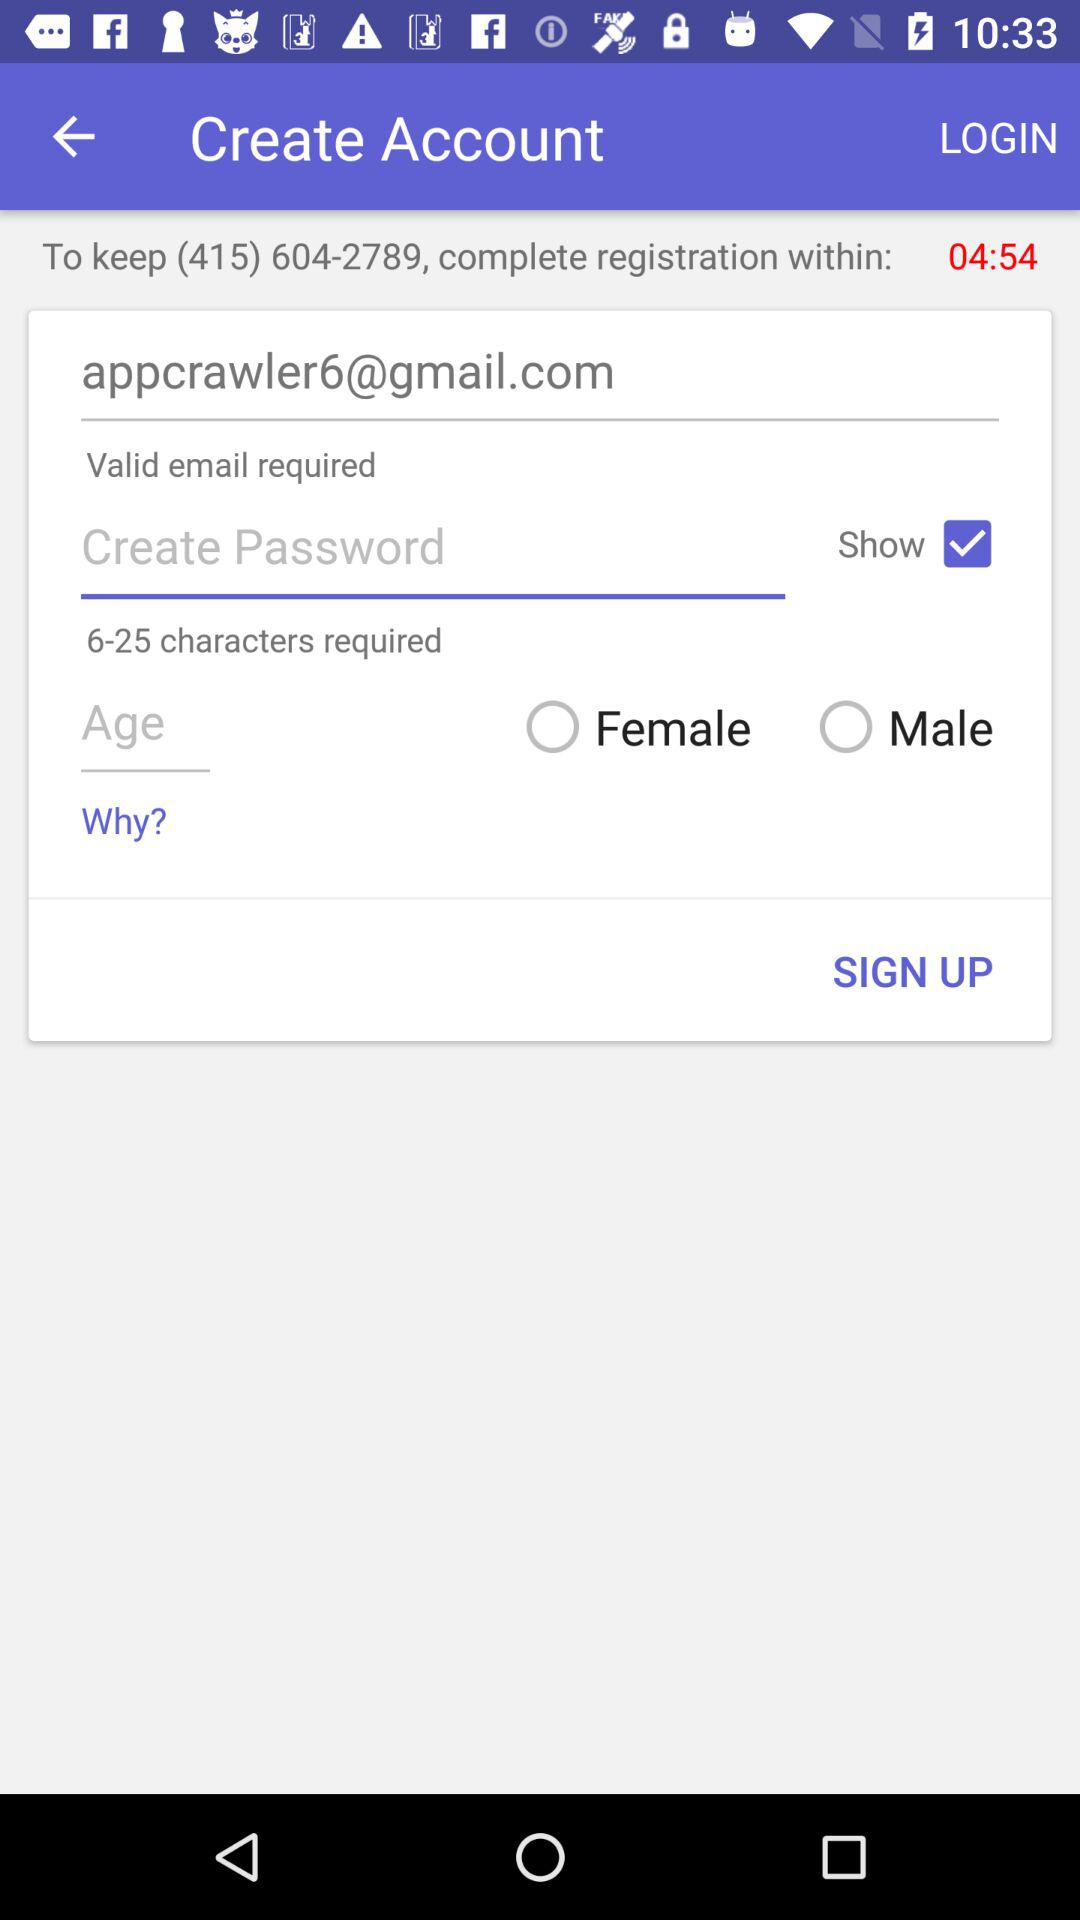In how much time do we have to complete the registration? You have to complete the registration in 4 minutes and 54 seconds. 